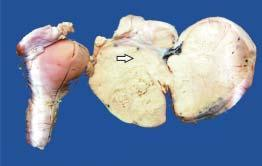what shows enlarged ovarian mass on one side which on cut section is solid, grey-white and firm?
Answer the question using a single word or phrase. Specimen of the uterus 